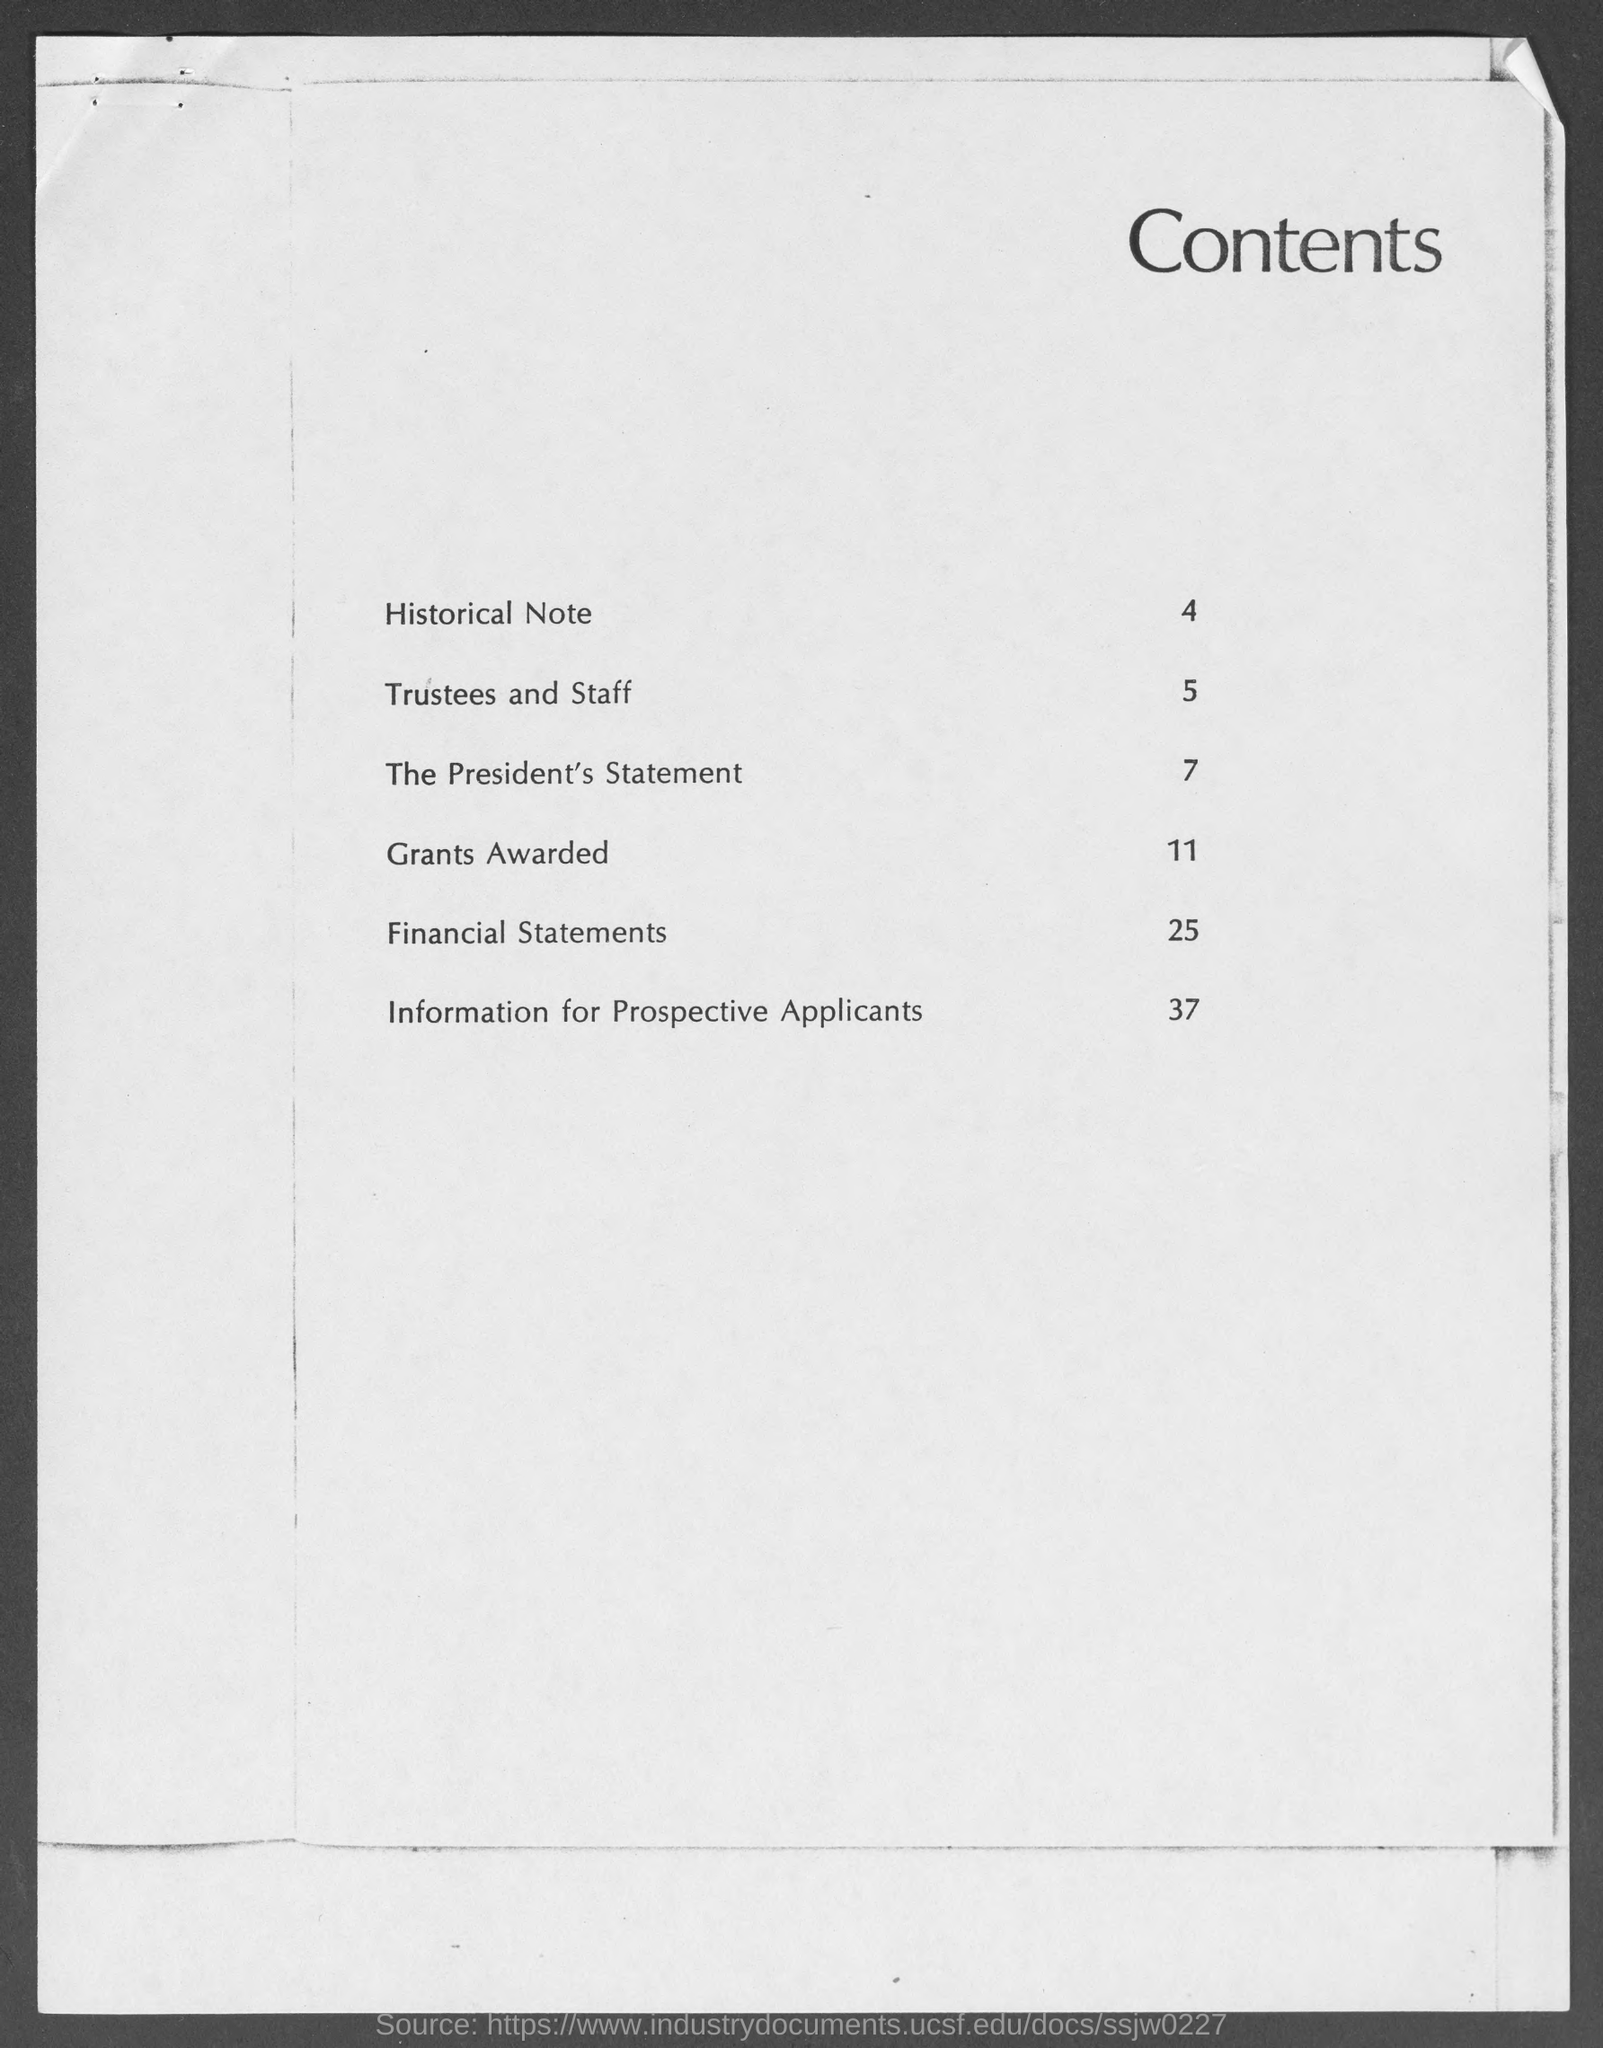What is the heading at top of the page ?
Provide a succinct answer. Contents. 